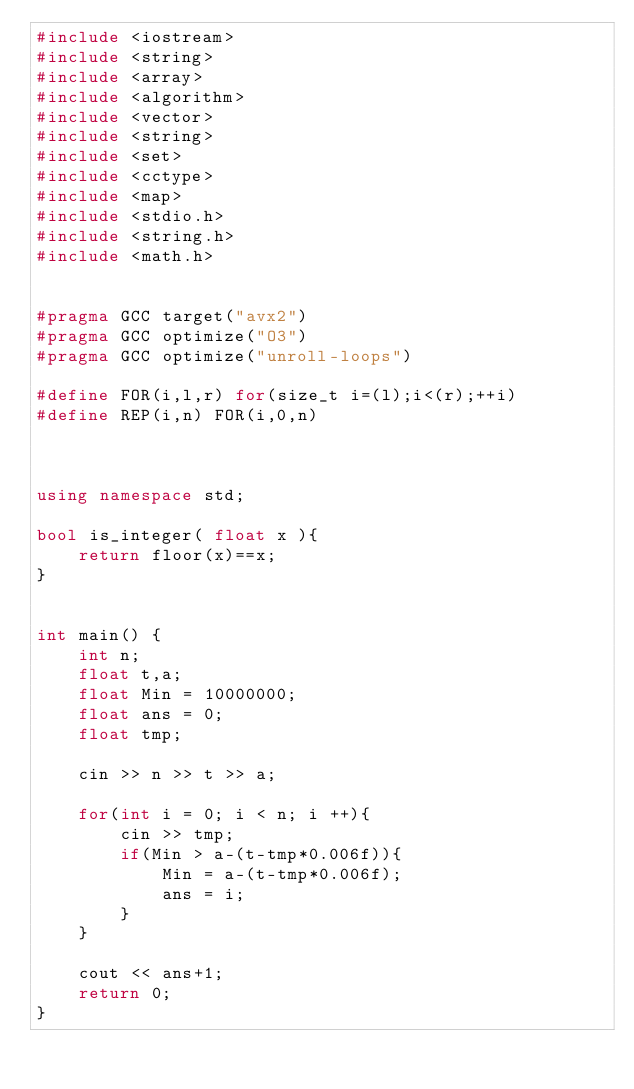<code> <loc_0><loc_0><loc_500><loc_500><_C++_>#include <iostream>
#include <string>
#include <array>
#include <algorithm>
#include <vector>
#include <string>
#include <set>
#include <cctype>
#include <map>
#include <stdio.h>
#include <string.h>
#include <math.h>


#pragma GCC target("avx2")
#pragma GCC optimize("O3")
#pragma GCC optimize("unroll-loops")

#define FOR(i,l,r) for(size_t i=(l);i<(r);++i)
#define REP(i,n) FOR(i,0,n)



using namespace std;

bool is_integer( float x ){
    return floor(x)==x;
}


int main() {
    int n;
    float t,a;
    float Min = 10000000;
    float ans = 0;
    float tmp;

    cin >> n >> t >> a;

    for(int i = 0; i < n; i ++){
        cin >> tmp;
        if(Min > a-(t-tmp*0.006f)){
            Min = a-(t-tmp*0.006f);
            ans = i;
        }
    }

    cout << ans+1;
    return 0;
}









</code> 